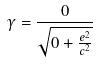Convert formula to latex. <formula><loc_0><loc_0><loc_500><loc_500>\gamma = \frac { 0 } { \sqrt { 0 + \frac { e ^ { 2 } } { c ^ { 2 } } } }</formula> 